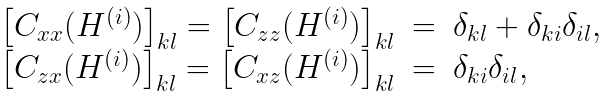<formula> <loc_0><loc_0><loc_500><loc_500>\begin{array} { r c l } { \left [ C _ { x x } ( H ^ { ( i ) } ) \right ] } _ { k l } = { \left [ C _ { z z } ( H ^ { ( i ) } ) \right ] } _ { k l } & = & \delta _ { k l } + \delta _ { k i } \delta _ { i l } , \\ { \left [ C _ { z x } ( H ^ { ( i ) } ) \right ] } _ { k l } = { \left [ C _ { x z } ( H ^ { ( i ) } ) \right ] } _ { k l } & = & \delta _ { k i } \delta _ { i l } , \end{array}</formula> 